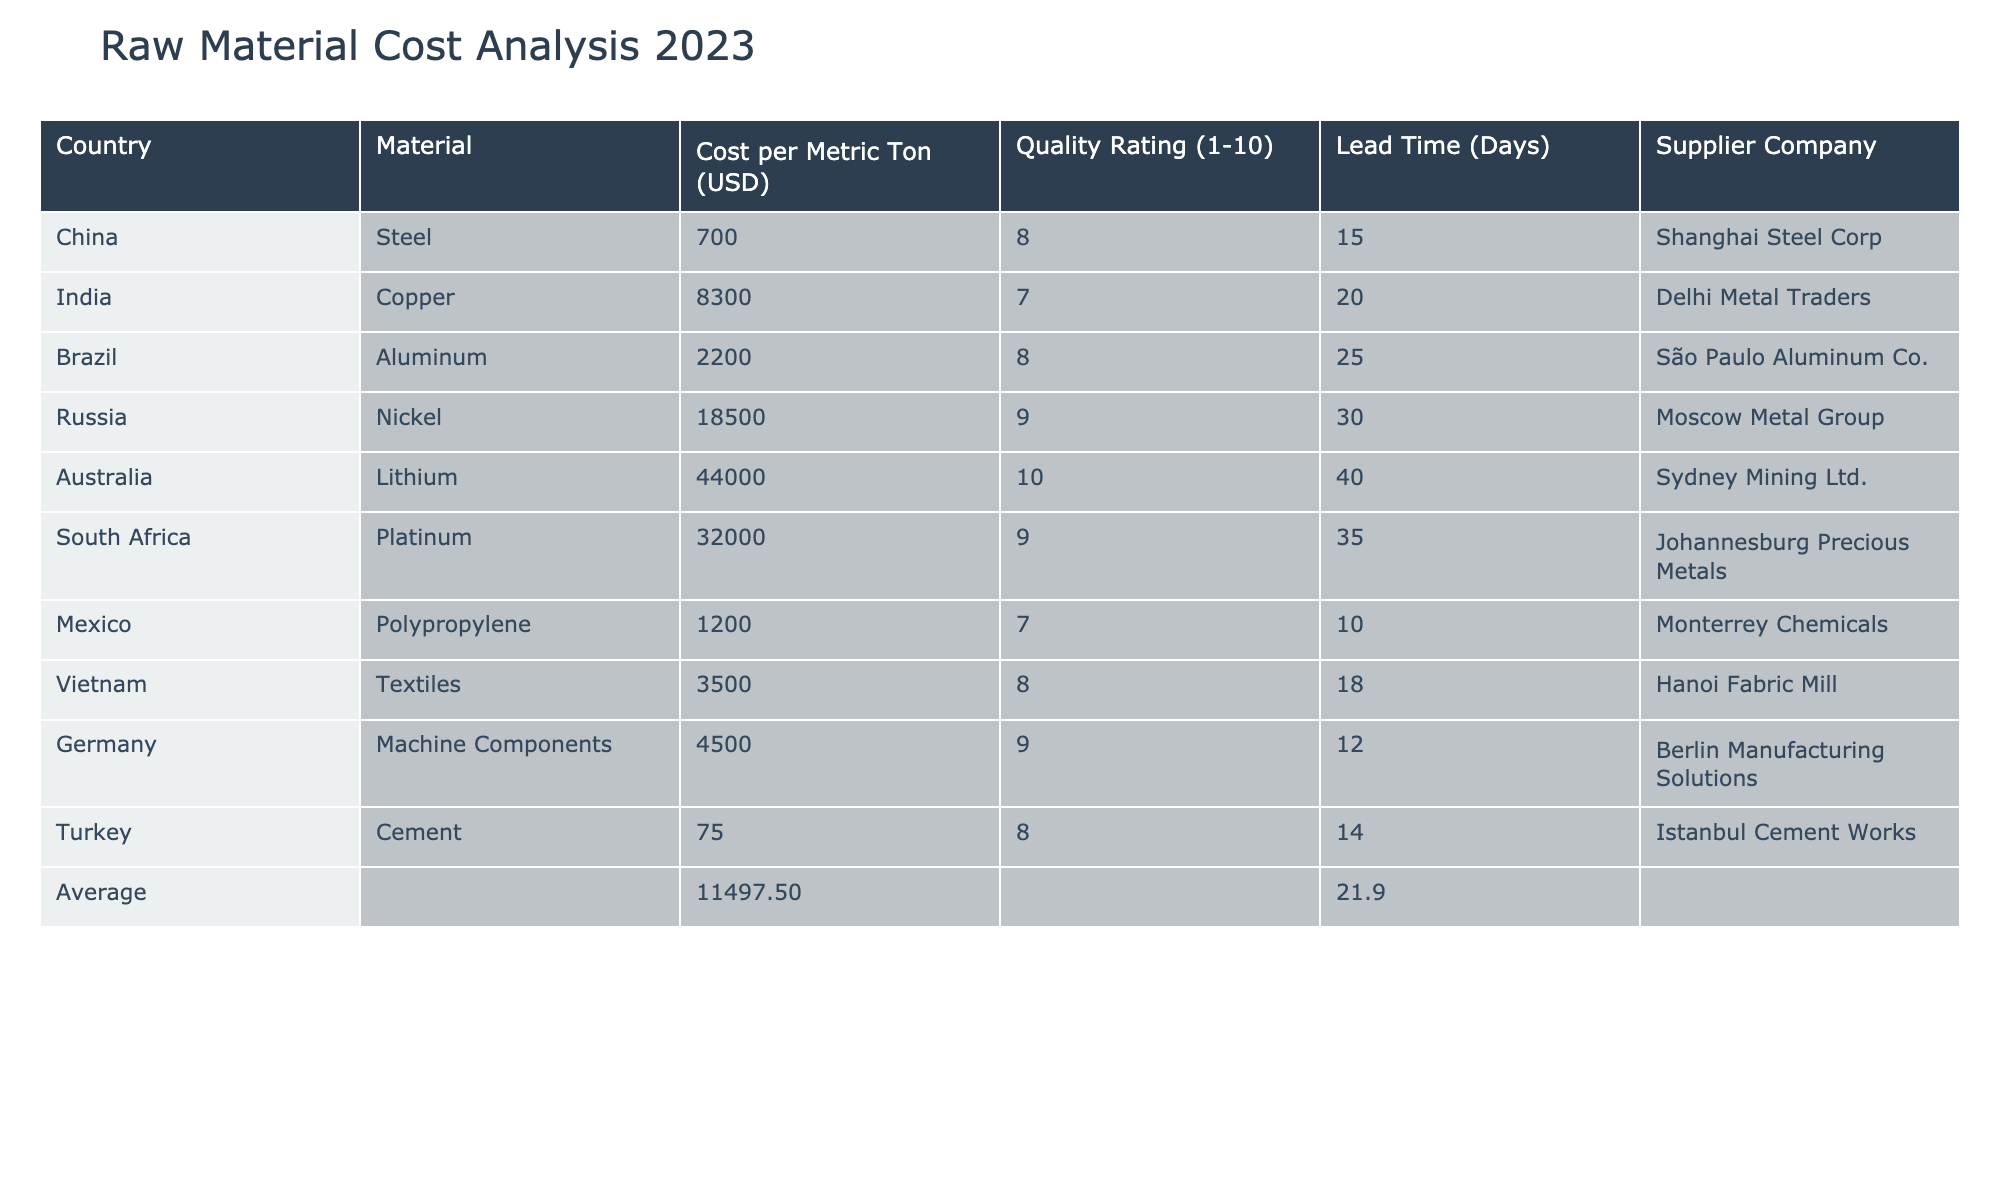What is the cost per metric ton for aluminum sourced from Brazil? The table lists Brazil under the 'Country' column, with 'Aluminum' as the corresponding material. The 'Cost per Metric Ton (USD)' column shows a value of 2200 for aluminum from Brazil.
Answer: 2200 Which country has the highest quality rating for raw materials? The 'Quality Rating (1-10)' column indicates that Australia has a quantity rating of 10 for lithium, which is the highest rating listed in the table.
Answer: Australia Is the average cost per metric ton of the raw materials listed above above or below 10,000 USD? First, calculate the average cost using provided costs: (700 + 8300 + 2200 + 18500 + 44000 + 32000 + 1200 + 3500 + 4500 + 75) = 114,475. Then divide by the number of materials (10): 114,475 / 10 = 11,447.5, which is above 10,000.
Answer: Above What is the lead time for copper sourced from India? By looking at the 'Country' and 'Material' columns, copper is sourced from India, and the corresponding 'Lead Time (Days)' value in the table is 20 days.
Answer: 20 days If we combine the costs of steel from China and cement from Turkey, what is their total cost? The cost of steel from China is 700 USD, and the cost of cement from Turkey is 75 USD. Adding these two amounts together gives 700 + 75 = 775 USD.
Answer: 775 Are there any materials sourced from countries with a quality rating below 8? By examining the quality ratings listed, both copper from India (7) and polypropylene from Mexico (7) have ratings below 8, confirming the statement is true.
Answer: Yes What is the average lead time for all materials listed in the table? First, sum the lead times: (15 + 20 + 25 + 30 + 40 + 35 + 10 + 18 + 12 + 14) =  239. Then divide by the number of materials (10): 239 / 10 = 23.9 days.
Answer: 23.9 days Which country has the lowest cost per metric ton for raw materials? A glance at the 'Cost per Metric Ton (USD)' column shows that Turkey has the lowest cost for cement, listed as 75 USD, making it the lowest.
Answer: Turkey What materials have a lead time greater than 20 days? A review of the 'Lead Time (Days)' column shows that Australia (40), Russia (30), and South Africa (35) have lead times greater than 20 days.
Answer: Australia, Russia, South Africa 